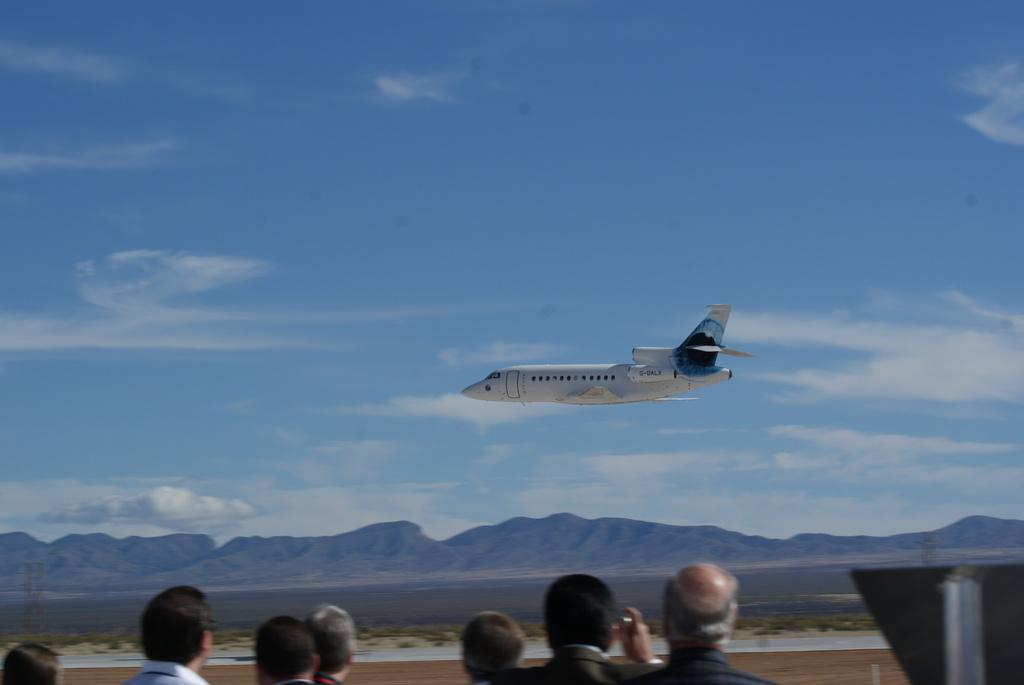What is the main subject of the image? The main subject of the image is an airplane. What is the airplane doing in the image? The airplane is flying in the sky. What can be seen in the background of the image? There are hills visible in the background of the image. Are there any people in the image? Yes, there is a group of people in front of the airplane. What type of fish can be seen swimming in the sky in the image? There are no fish visible in the image, and fish cannot swim in the sky. 